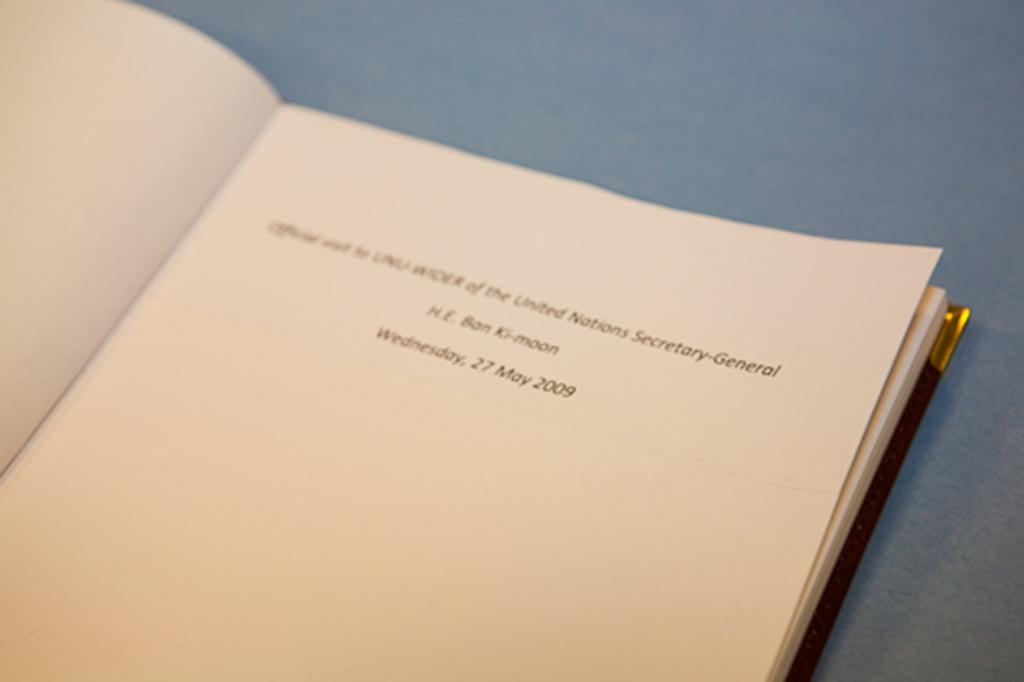<image>
Present a compact description of the photo's key features. A book page that includes  the United Nations Secretary by H.E. Ban Ki-moon. 